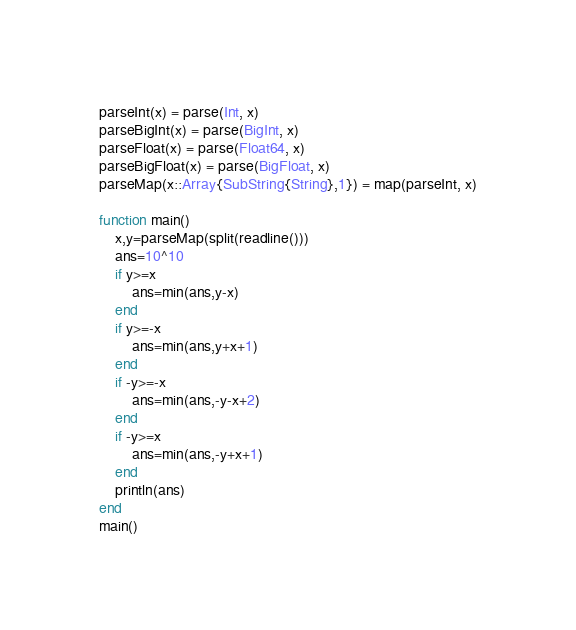Convert code to text. <code><loc_0><loc_0><loc_500><loc_500><_Julia_>parseInt(x) = parse(Int, x)
parseBigInt(x) = parse(BigInt, x)
parseFloat(x) = parse(Float64, x)
parseBigFloat(x) = parse(BigFloat, x)
parseMap(x::Array{SubString{String},1}) = map(parseInt, x)

function main()
    x,y=parseMap(split(readline()))
    ans=10^10
    if y>=x
        ans=min(ans,y-x)
    end
    if y>=-x
        ans=min(ans,y+x+1)
    end
    if -y>=-x
        ans=min(ans,-y-x+2)
    end
    if -y>=x
        ans=min(ans,-y+x+1)
    end
    println(ans)
end
main()</code> 